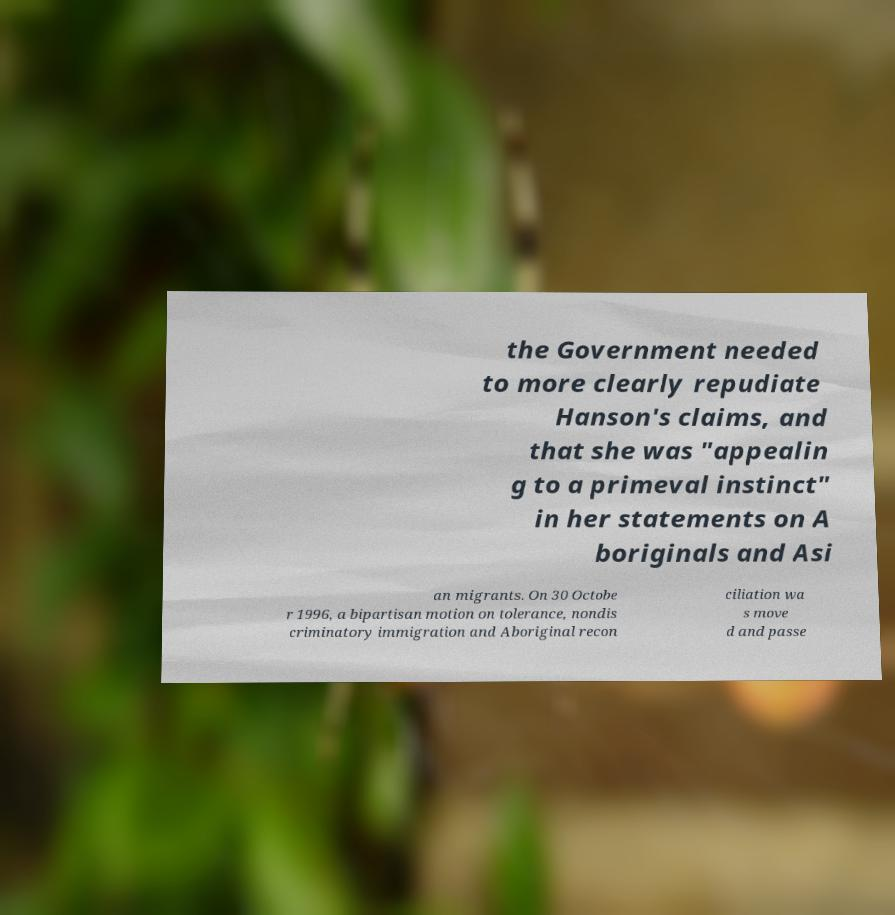Please identify and transcribe the text found in this image. the Government needed to more clearly repudiate Hanson's claims, and that she was "appealin g to a primeval instinct" in her statements on A boriginals and Asi an migrants. On 30 Octobe r 1996, a bipartisan motion on tolerance, nondis criminatory immigration and Aboriginal recon ciliation wa s move d and passe 